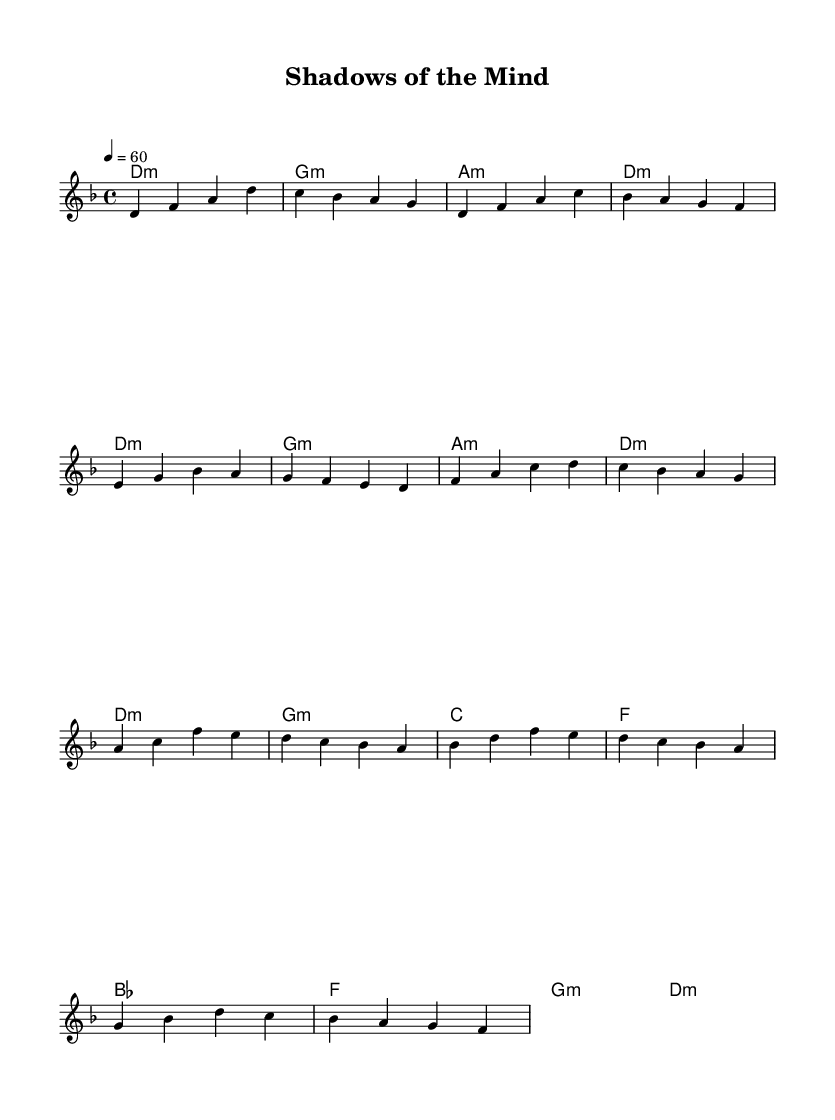What is the key signature of this music? The key signature is D minor, which has one flat, B flat.
Answer: D minor What is the time signature of this music? The time signature is 4/4, indicating four beats per measure.
Answer: 4/4 What is the tempo marking of this music? The tempo marking is quarter note equals sixty, indicating a slow pace of sixty beats per minute.
Answer: 60 How many measures are in the introduction? The introduction consists of four measures. This can be counted from the introductory melody provided before the verse begins.
Answer: 4 In the chorus, what chord follows F major? In the chorus, the chord that follows F major is D minor, which is derived from examining the chord progression in the chorus.
Answer: D minor What is the mood conveyed by the song's key and tempo? The song's key of D minor and slow tempo suggest a somber, melancholic mood, typical of confronting inner demons as reflected in soul music.
Answer: Somber How many different chords are used in the music? There are six unique chords in the music: D minor, G minor, A minor, C major, F major, and B flat major. This totals the distinct types found in the harmony section throughout the piece.
Answer: 6 